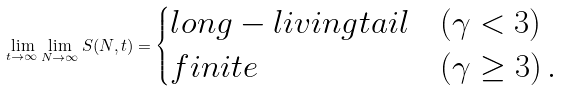Convert formula to latex. <formula><loc_0><loc_0><loc_500><loc_500>\lim _ { t \rightarrow \infty } \lim _ { N \rightarrow \infty } S ( N , t ) = \begin{cases} l o n g - l i v i n g t a i l & ( \gamma < 3 ) \\ f i n i t e & ( \gamma \geq 3 ) \, . \end{cases}</formula> 